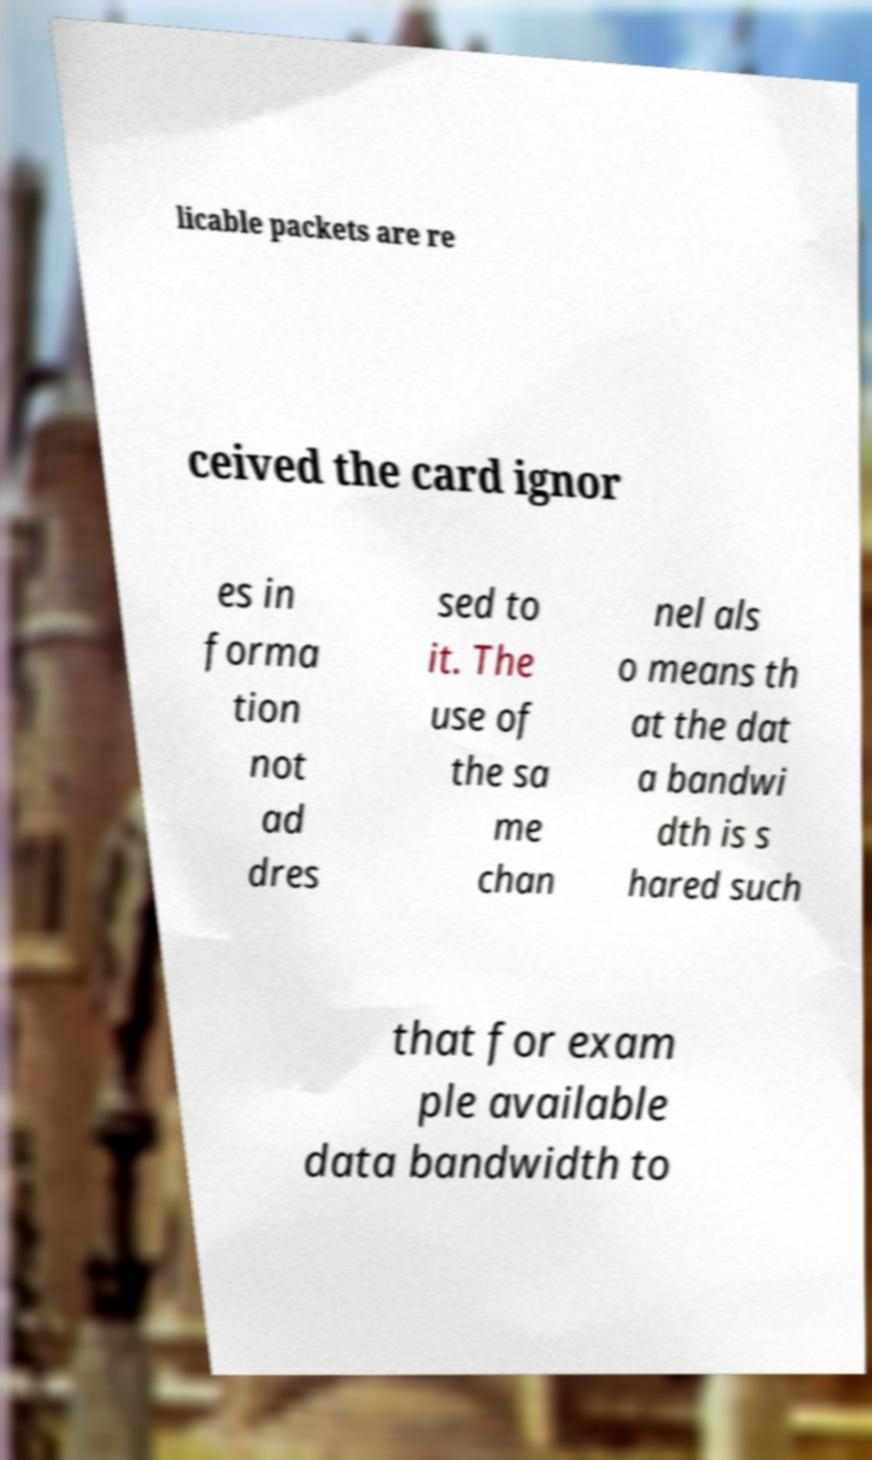For documentation purposes, I need the text within this image transcribed. Could you provide that? licable packets are re ceived the card ignor es in forma tion not ad dres sed to it. The use of the sa me chan nel als o means th at the dat a bandwi dth is s hared such that for exam ple available data bandwidth to 